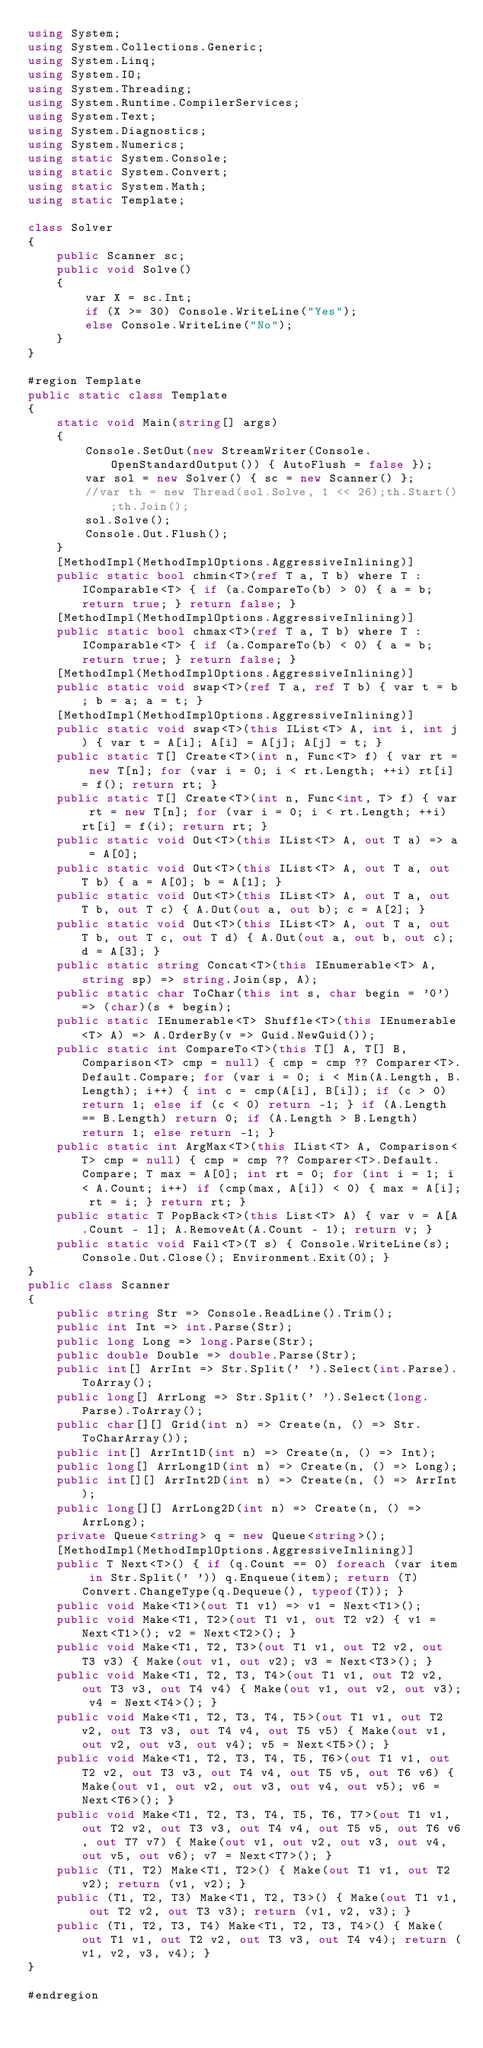Convert code to text. <code><loc_0><loc_0><loc_500><loc_500><_C#_>using System;
using System.Collections.Generic;
using System.Linq;
using System.IO;
using System.Threading;
using System.Runtime.CompilerServices;
using System.Text;
using System.Diagnostics;
using System.Numerics;
using static System.Console;
using static System.Convert;
using static System.Math;
using static Template;

class Solver
{
    public Scanner sc;
    public void Solve()
    {
        var X = sc.Int;
        if (X >= 30) Console.WriteLine("Yes");
        else Console.WriteLine("No");
    }
}

#region Template
public static class Template
{
    static void Main(string[] args)
    {
        Console.SetOut(new StreamWriter(Console.OpenStandardOutput()) { AutoFlush = false });
        var sol = new Solver() { sc = new Scanner() };
        //var th = new Thread(sol.Solve, 1 << 26);th.Start();th.Join();
        sol.Solve();
        Console.Out.Flush();
    }
    [MethodImpl(MethodImplOptions.AggressiveInlining)]
    public static bool chmin<T>(ref T a, T b) where T : IComparable<T> { if (a.CompareTo(b) > 0) { a = b; return true; } return false; }
    [MethodImpl(MethodImplOptions.AggressiveInlining)]
    public static bool chmax<T>(ref T a, T b) where T : IComparable<T> { if (a.CompareTo(b) < 0) { a = b; return true; } return false; }
    [MethodImpl(MethodImplOptions.AggressiveInlining)]
    public static void swap<T>(ref T a, ref T b) { var t = b; b = a; a = t; }
    [MethodImpl(MethodImplOptions.AggressiveInlining)]
    public static void swap<T>(this IList<T> A, int i, int j) { var t = A[i]; A[i] = A[j]; A[j] = t; }
    public static T[] Create<T>(int n, Func<T> f) { var rt = new T[n]; for (var i = 0; i < rt.Length; ++i) rt[i] = f(); return rt; }
    public static T[] Create<T>(int n, Func<int, T> f) { var rt = new T[n]; for (var i = 0; i < rt.Length; ++i) rt[i] = f(i); return rt; }
    public static void Out<T>(this IList<T> A, out T a) => a = A[0];
    public static void Out<T>(this IList<T> A, out T a, out T b) { a = A[0]; b = A[1]; }
    public static void Out<T>(this IList<T> A, out T a, out T b, out T c) { A.Out(out a, out b); c = A[2]; }
    public static void Out<T>(this IList<T> A, out T a, out T b, out T c, out T d) { A.Out(out a, out b, out c); d = A[3]; }
    public static string Concat<T>(this IEnumerable<T> A, string sp) => string.Join(sp, A);
    public static char ToChar(this int s, char begin = '0') => (char)(s + begin);
    public static IEnumerable<T> Shuffle<T>(this IEnumerable<T> A) => A.OrderBy(v => Guid.NewGuid());
    public static int CompareTo<T>(this T[] A, T[] B, Comparison<T> cmp = null) { cmp = cmp ?? Comparer<T>.Default.Compare; for (var i = 0; i < Min(A.Length, B.Length); i++) { int c = cmp(A[i], B[i]); if (c > 0) return 1; else if (c < 0) return -1; } if (A.Length == B.Length) return 0; if (A.Length > B.Length) return 1; else return -1; }
    public static int ArgMax<T>(this IList<T> A, Comparison<T> cmp = null) { cmp = cmp ?? Comparer<T>.Default.Compare; T max = A[0]; int rt = 0; for (int i = 1; i < A.Count; i++) if (cmp(max, A[i]) < 0) { max = A[i]; rt = i; } return rt; }
    public static T PopBack<T>(this List<T> A) { var v = A[A.Count - 1]; A.RemoveAt(A.Count - 1); return v; }
    public static void Fail<T>(T s) { Console.WriteLine(s); Console.Out.Close(); Environment.Exit(0); }
}
public class Scanner
{
    public string Str => Console.ReadLine().Trim();
    public int Int => int.Parse(Str);
    public long Long => long.Parse(Str);
    public double Double => double.Parse(Str);
    public int[] ArrInt => Str.Split(' ').Select(int.Parse).ToArray();
    public long[] ArrLong => Str.Split(' ').Select(long.Parse).ToArray();
    public char[][] Grid(int n) => Create(n, () => Str.ToCharArray());
    public int[] ArrInt1D(int n) => Create(n, () => Int);
    public long[] ArrLong1D(int n) => Create(n, () => Long);
    public int[][] ArrInt2D(int n) => Create(n, () => ArrInt);
    public long[][] ArrLong2D(int n) => Create(n, () => ArrLong);
    private Queue<string> q = new Queue<string>();
    [MethodImpl(MethodImplOptions.AggressiveInlining)]
    public T Next<T>() { if (q.Count == 0) foreach (var item in Str.Split(' ')) q.Enqueue(item); return (T)Convert.ChangeType(q.Dequeue(), typeof(T)); }
    public void Make<T1>(out T1 v1) => v1 = Next<T1>();
    public void Make<T1, T2>(out T1 v1, out T2 v2) { v1 = Next<T1>(); v2 = Next<T2>(); }
    public void Make<T1, T2, T3>(out T1 v1, out T2 v2, out T3 v3) { Make(out v1, out v2); v3 = Next<T3>(); }
    public void Make<T1, T2, T3, T4>(out T1 v1, out T2 v2, out T3 v3, out T4 v4) { Make(out v1, out v2, out v3); v4 = Next<T4>(); }
    public void Make<T1, T2, T3, T4, T5>(out T1 v1, out T2 v2, out T3 v3, out T4 v4, out T5 v5) { Make(out v1, out v2, out v3, out v4); v5 = Next<T5>(); }
    public void Make<T1, T2, T3, T4, T5, T6>(out T1 v1, out T2 v2, out T3 v3, out T4 v4, out T5 v5, out T6 v6) { Make(out v1, out v2, out v3, out v4, out v5); v6 = Next<T6>(); }
    public void Make<T1, T2, T3, T4, T5, T6, T7>(out T1 v1, out T2 v2, out T3 v3, out T4 v4, out T5 v5, out T6 v6, out T7 v7) { Make(out v1, out v2, out v3, out v4, out v5, out v6); v7 = Next<T7>(); }
    public (T1, T2) Make<T1, T2>() { Make(out T1 v1, out T2 v2); return (v1, v2); }
    public (T1, T2, T3) Make<T1, T2, T3>() { Make(out T1 v1, out T2 v2, out T3 v3); return (v1, v2, v3); }
    public (T1, T2, T3, T4) Make<T1, T2, T3, T4>() { Make(out T1 v1, out T2 v2, out T3 v3, out T4 v4); return (v1, v2, v3, v4); }
}

#endregion</code> 